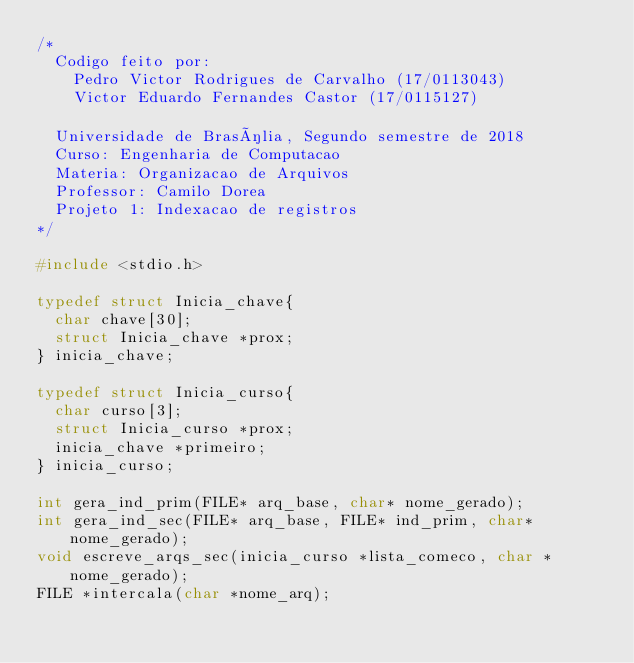<code> <loc_0><loc_0><loc_500><loc_500><_C_>/*
	Codigo feito por:
		Pedro Victor Rodrigues de Carvalho (17/0113043)
		Victor Eduardo Fernandes Castor	(17/0115127)

	Universidade de Brasília, Segundo semestre de 2018
	Curso: Engenharia de Computacao
	Materia: Organizacao de Arquivos
	Professor: Camilo Dorea
	Projeto 1: Indexacao de registros
*/

#include <stdio.h>

typedef struct Inicia_chave{
	char chave[30];
	struct Inicia_chave *prox;
} inicia_chave;

typedef struct Inicia_curso{
	char curso[3];
	struct Inicia_curso *prox;
	inicia_chave *primeiro;
} inicia_curso;

int gera_ind_prim(FILE* arq_base, char* nome_gerado);
int gera_ind_sec(FILE* arq_base, FILE* ind_prim, char* nome_gerado);
void escreve_arqs_sec(inicia_curso *lista_comeco, char *nome_gerado);
FILE *intercala(char *nome_arq);
</code> 